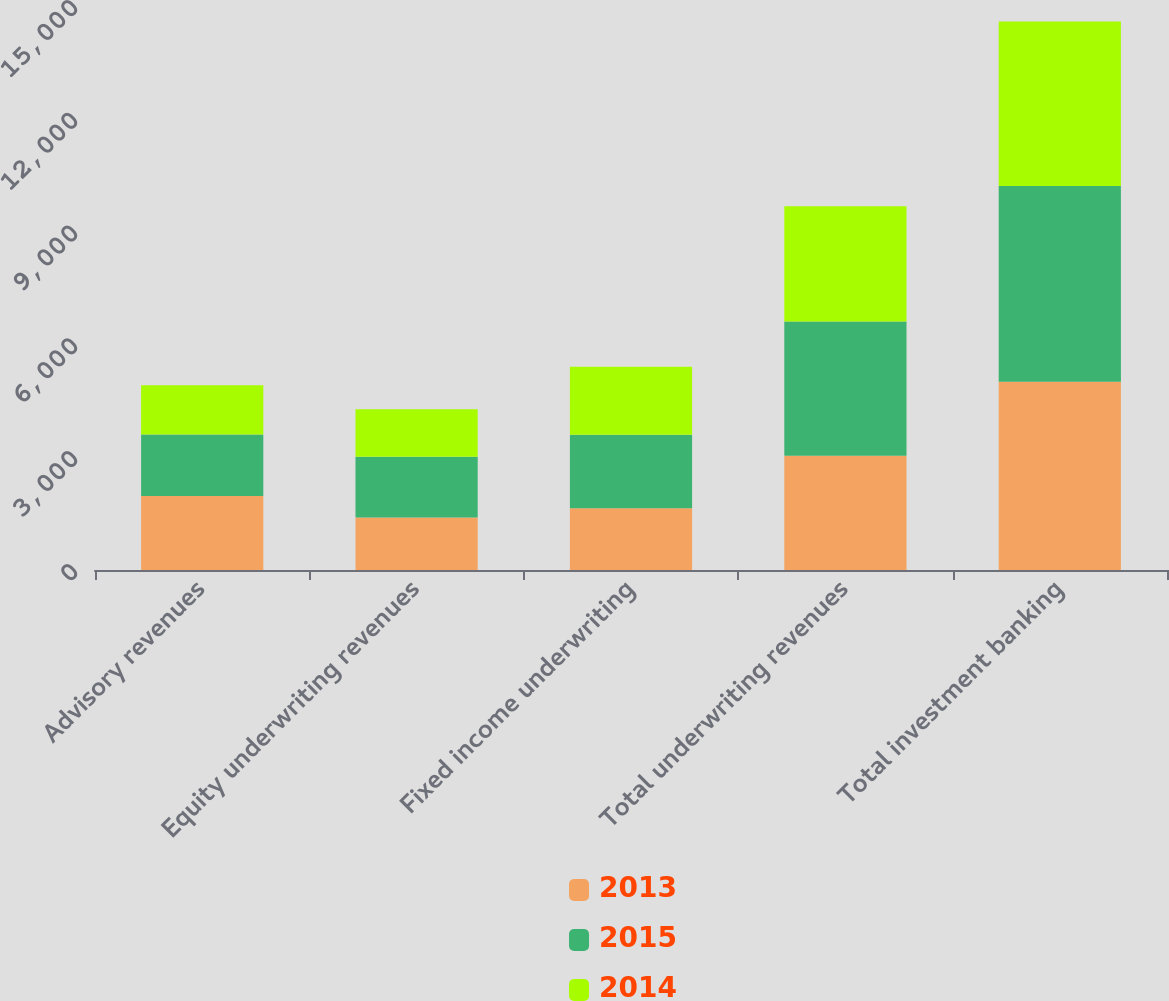Convert chart. <chart><loc_0><loc_0><loc_500><loc_500><stacked_bar_chart><ecel><fcel>Advisory revenues<fcel>Equity underwriting revenues<fcel>Fixed income underwriting<fcel>Total underwriting revenues<fcel>Total investment banking<nl><fcel>2013<fcel>1967<fcel>1398<fcel>1643<fcel>3041<fcel>5008<nl><fcel>2015<fcel>1634<fcel>1613<fcel>1956<fcel>3569<fcel>5203<nl><fcel>2014<fcel>1310<fcel>1262<fcel>1805<fcel>3067<fcel>4377<nl></chart> 